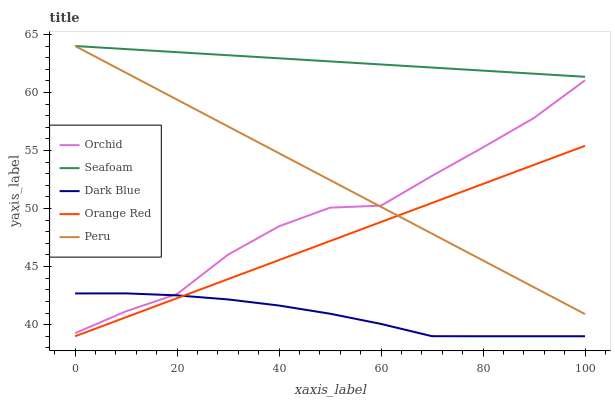Does Dark Blue have the minimum area under the curve?
Answer yes or no. Yes. Does Seafoam have the maximum area under the curve?
Answer yes or no. Yes. Does Seafoam have the minimum area under the curve?
Answer yes or no. No. Does Dark Blue have the maximum area under the curve?
Answer yes or no. No. Is Peru the smoothest?
Answer yes or no. Yes. Is Orchid the roughest?
Answer yes or no. Yes. Is Dark Blue the smoothest?
Answer yes or no. No. Is Dark Blue the roughest?
Answer yes or no. No. Does Dark Blue have the lowest value?
Answer yes or no. Yes. Does Seafoam have the lowest value?
Answer yes or no. No. Does Seafoam have the highest value?
Answer yes or no. Yes. Does Dark Blue have the highest value?
Answer yes or no. No. Is Orchid less than Seafoam?
Answer yes or no. Yes. Is Orchid greater than Orange Red?
Answer yes or no. Yes. Does Seafoam intersect Peru?
Answer yes or no. Yes. Is Seafoam less than Peru?
Answer yes or no. No. Is Seafoam greater than Peru?
Answer yes or no. No. Does Orchid intersect Seafoam?
Answer yes or no. No. 